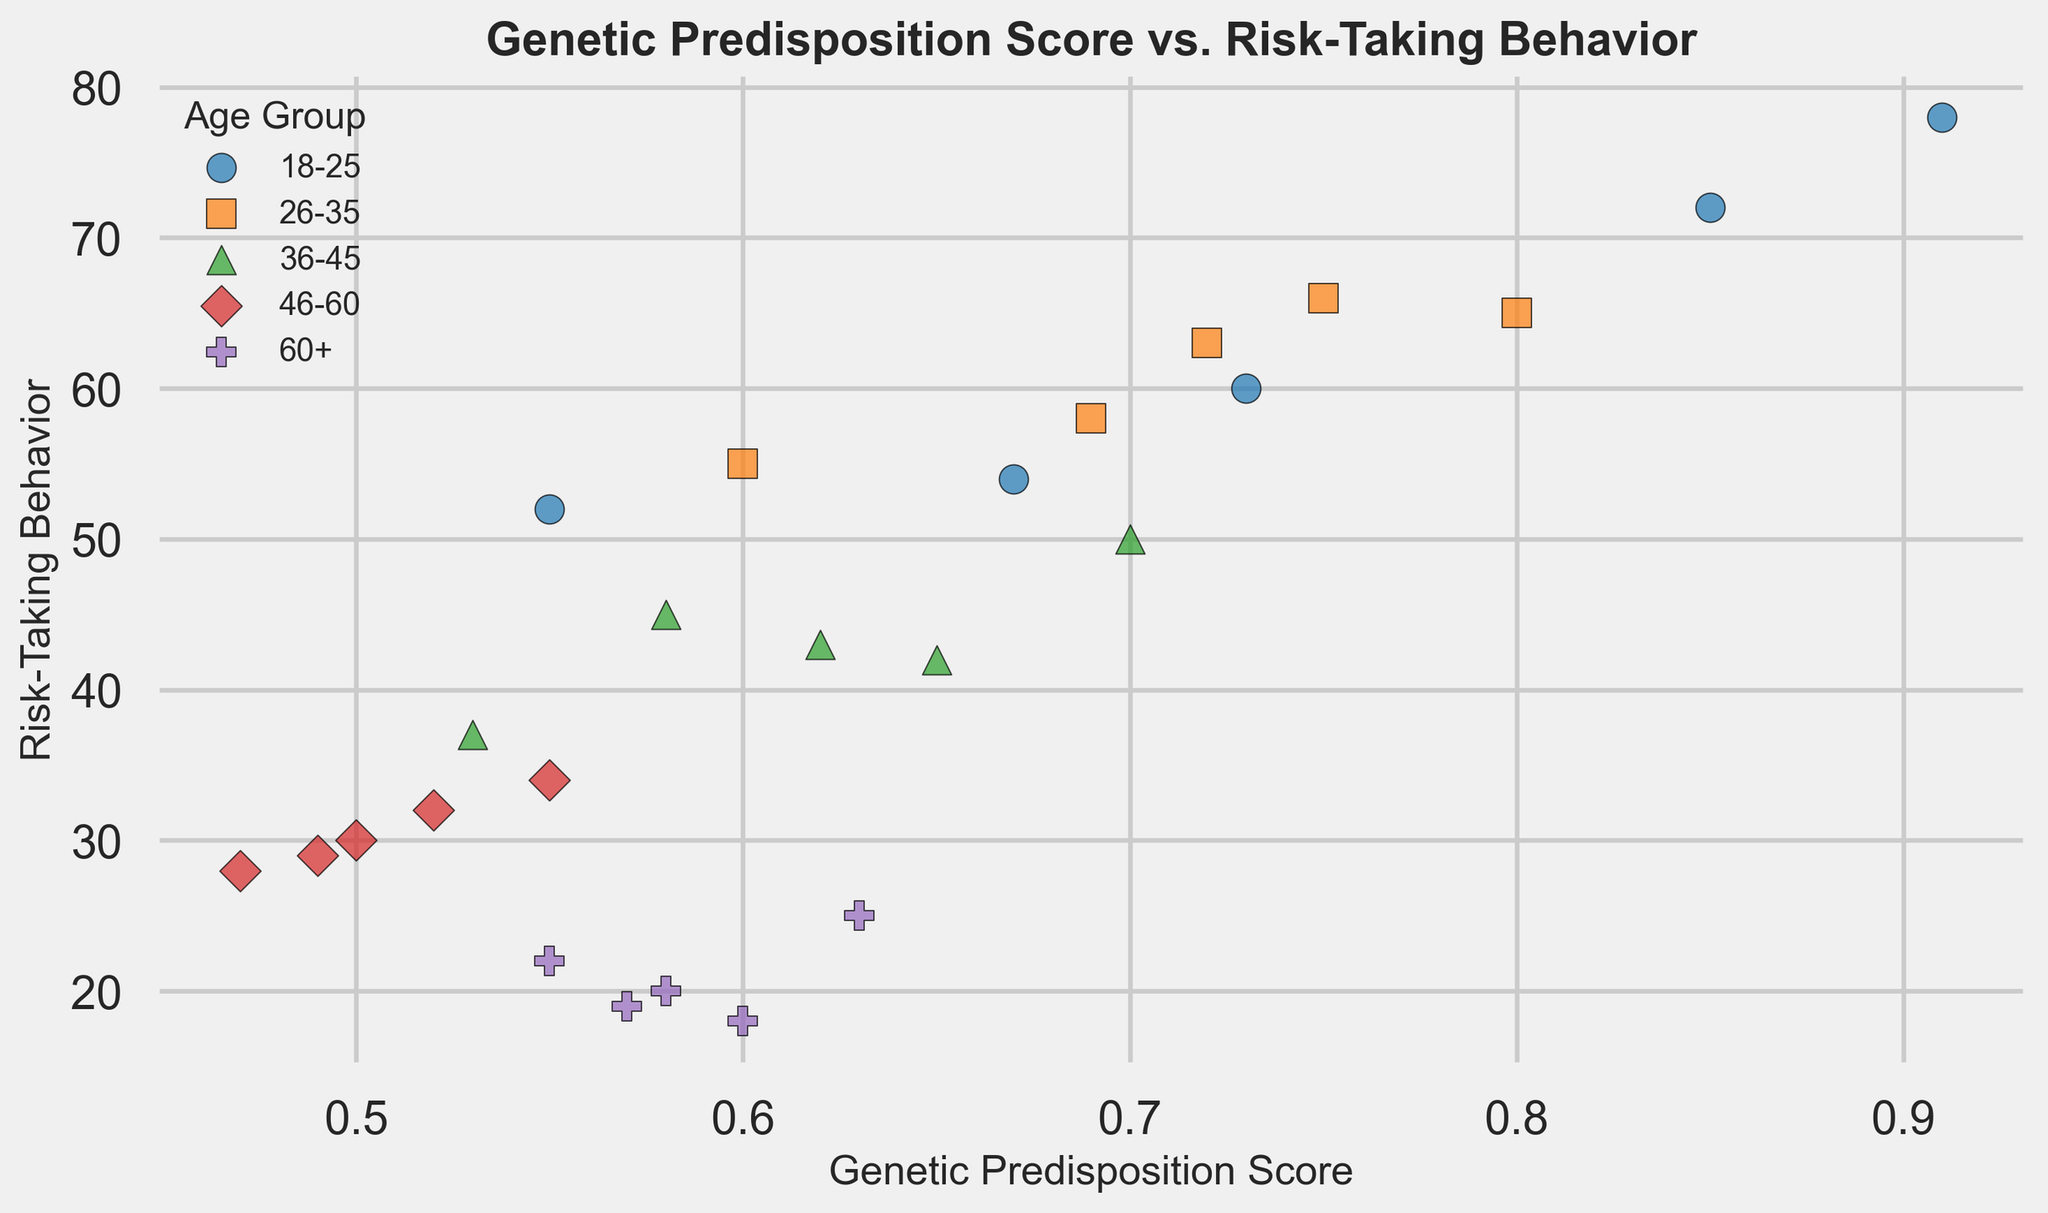What is the general trend of risk-taking behavior as the genetic predisposition score increases? We observe that, especially in younger age groups (18-25 and 26-35), risk-taking behavior tends to increase with higher genetic predisposition scores. In other age groups, the trend is less pronounced. This overall trend suggests a positive correlation between genetic predisposition score and risk-taking behavior.
Answer: Positive correlation Which age group shows the highest level of risk-taking behavior? The data points for the age group 18-25 are situated at higher risk-taking behavior values compared to other age groups. By looking at the scatter plot, we can see that 18-25 has the highest levels of risk-taking behavior, with data points reaching values up to 78.
Answer: 18-25 How do the risk-taking behaviors of individuals aged 26-35 compare to those aged 46-60? We can observe that the data points for the age group 26-35 are scattered at higher values compared to those for the 46-60 age group. This shows that individuals aged 26-35 generally have higher risk-taking behaviors than those aged 46-60.
Answer: Higher Is there any overlap in genetic predisposition scores between the age groups? Yes, by examining where the scatter points for different age groups overlap on the x-axis (genetic predisposition score), we see that different age groups share overlapping ranges. For example, both 18-25 and 26-35 have data points around scores of 0.7-0.8.
Answer: Yes Which age group has the widest range of genetic predisposition scores? By looking at the scatter plot along the x-axis, the age group 18-25 shows the widest range of genetic predisposition scores, varying from around 0.55 to 0.91.
Answer: 18-25 What is the average risk-taking behavior for individuals aged 60+? The risk-taking behaviors recorded for the 60+ age group are 18, 20, 22, 25, and 19. Summing these values gives 104, and the average is calculated by dividing 104 by 5.
Answer: 20.8 How does the genetic predisposition score of individuals aged 36-45 with the highest risk-taking behavior compare to that of younger age groups? The highest risk-taking behavior in the 36-45 age group is 50, with a corresponding genetic predisposition score of 0.70. For younger age groups like 18-25 and 26-35, higher risk-taking behaviors correspond to somewhat higher genetic predisposition scores, often above 0.7.
Answer: Lower Which age group point in the scatter plot is represented by purple color? By referencing the colors used for different age groups in the legend of the scatter plot, we see that the points for the 46-60 age group are represented by the purple color.
Answer: 46-60 